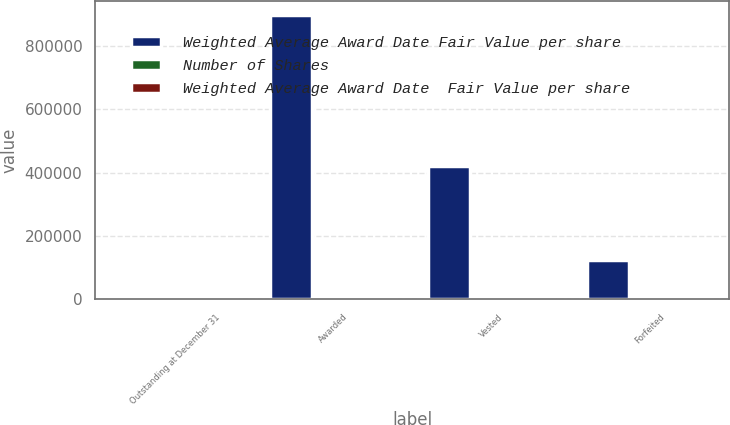Convert chart to OTSL. <chart><loc_0><loc_0><loc_500><loc_500><stacked_bar_chart><ecel><fcel>Outstanding at December 31<fcel>Awarded<fcel>Vested<fcel>Forfeited<nl><fcel>Weighted Average Award Date Fair Value per share<fcel>40.285<fcel>898916<fcel>421227<fcel>125379<nl><fcel>Number of Shares<fcel>36.37<fcel>31.67<fcel>52.5<fcel>35.54<nl><fcel>Weighted Average Award Date  Fair Value per share<fcel>27.43<fcel>24.8<fcel>42.71<fcel>37.86<nl></chart> 